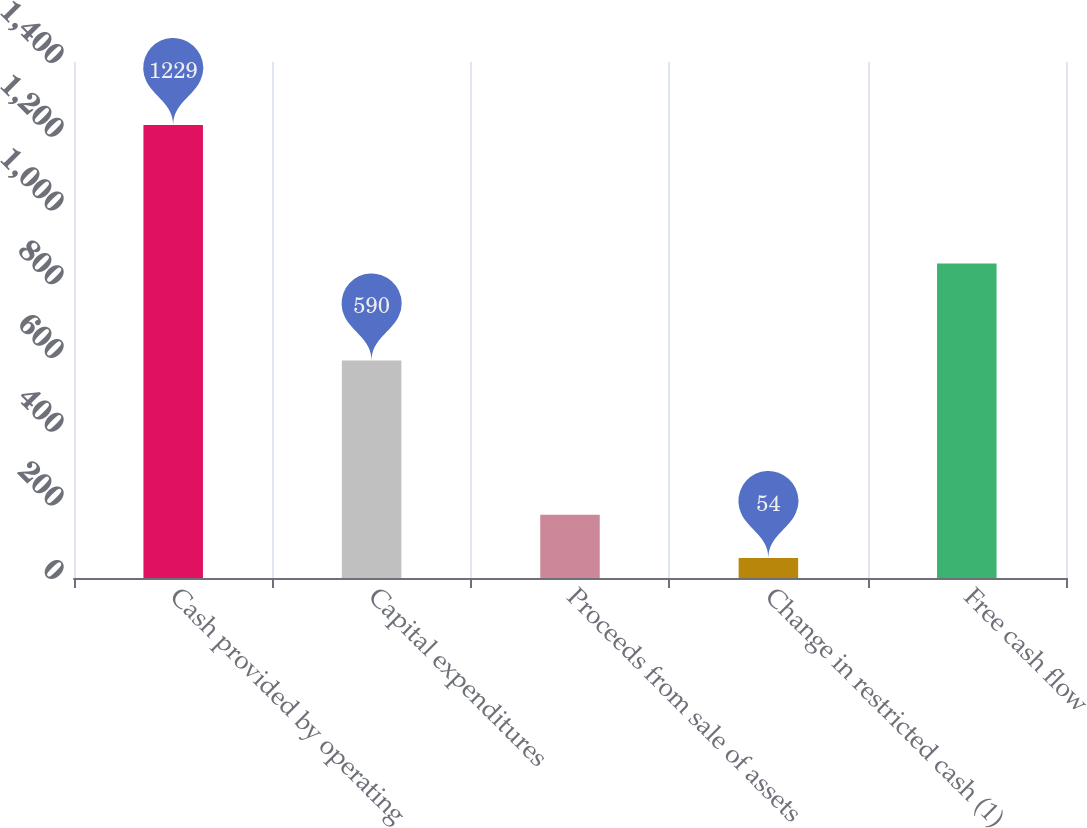Convert chart to OTSL. <chart><loc_0><loc_0><loc_500><loc_500><bar_chart><fcel>Cash provided by operating<fcel>Capital expenditures<fcel>Proceeds from sale of assets<fcel>Change in restricted cash (1)<fcel>Free cash flow<nl><fcel>1229<fcel>590<fcel>171.5<fcel>54<fcel>853<nl></chart> 